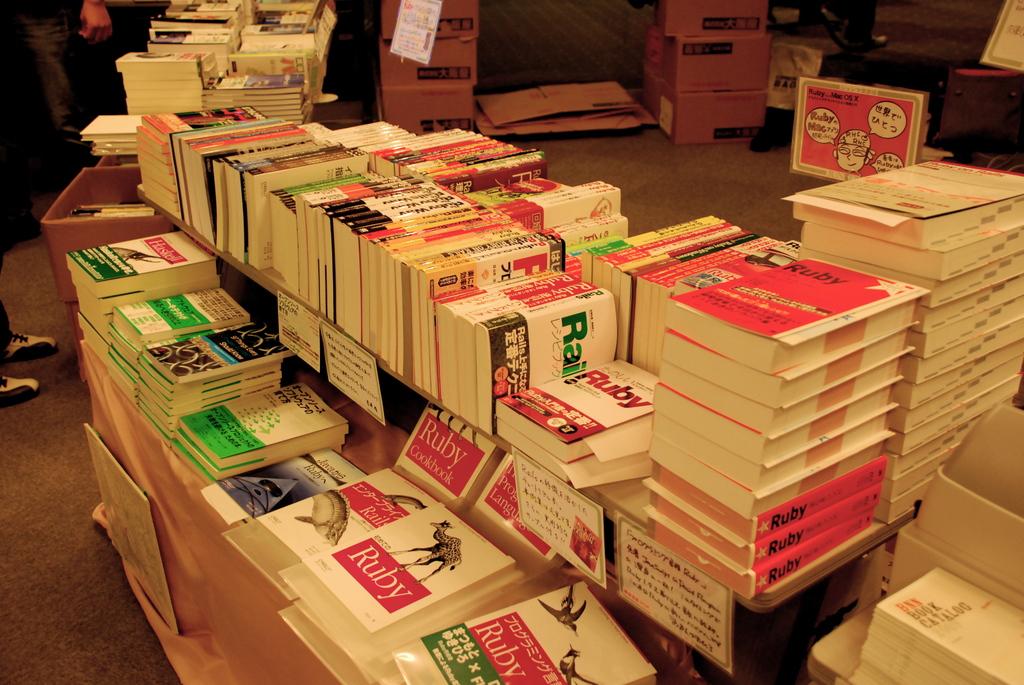What precious stone is listed on the book with the giraffe?
Your answer should be very brief. Ruby. 